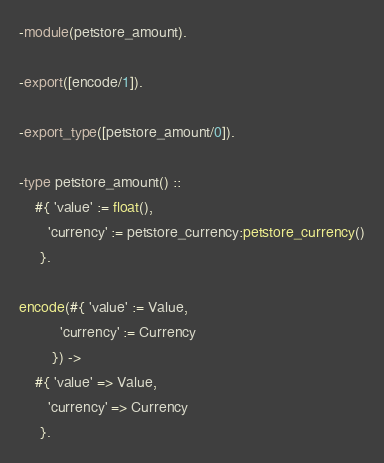<code> <loc_0><loc_0><loc_500><loc_500><_Erlang_>-module(petstore_amount).

-export([encode/1]).

-export_type([petstore_amount/0]).

-type petstore_amount() ::
    #{ 'value' := float(),
       'currency' := petstore_currency:petstore_currency()
     }.

encode(#{ 'value' := Value,
          'currency' := Currency
        }) ->
    #{ 'value' => Value,
       'currency' => Currency
     }.
</code> 